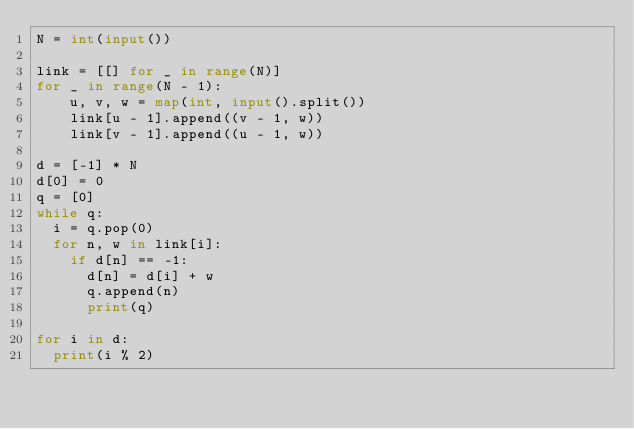<code> <loc_0><loc_0><loc_500><loc_500><_Python_>N = int(input())
 
link = [[] for _ in range(N)]
for _ in range(N - 1):
    u, v, w = map(int, input().split())
    link[u - 1].append((v - 1, w))
    link[v - 1].append((u - 1, w))
 
d = [-1] * N
d[0] = 0
q = [0]
while q:
  i = q.pop(0)
  for n, w in link[i]:
    if d[n] == -1:
      d[n] = d[i] + w
      q.append(n)
      print(q)
 
for i in d:
  print(i % 2)</code> 